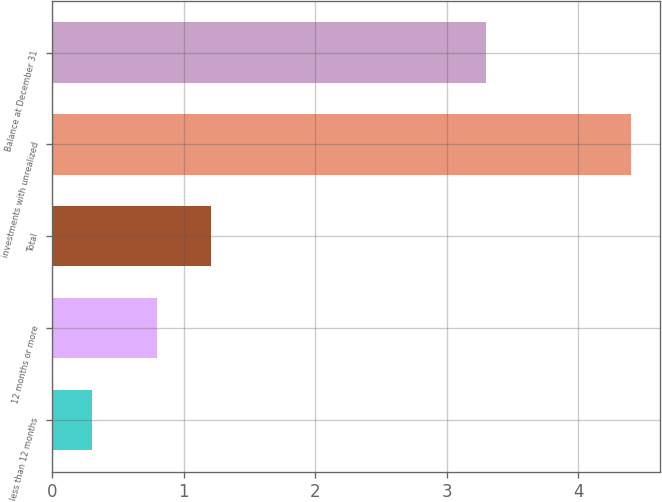Convert chart to OTSL. <chart><loc_0><loc_0><loc_500><loc_500><bar_chart><fcel>less than 12 months<fcel>12 months or more<fcel>Total<fcel>investments with unrealized<fcel>Balance at December 31<nl><fcel>0.3<fcel>0.8<fcel>1.21<fcel>4.4<fcel>3.3<nl></chart> 